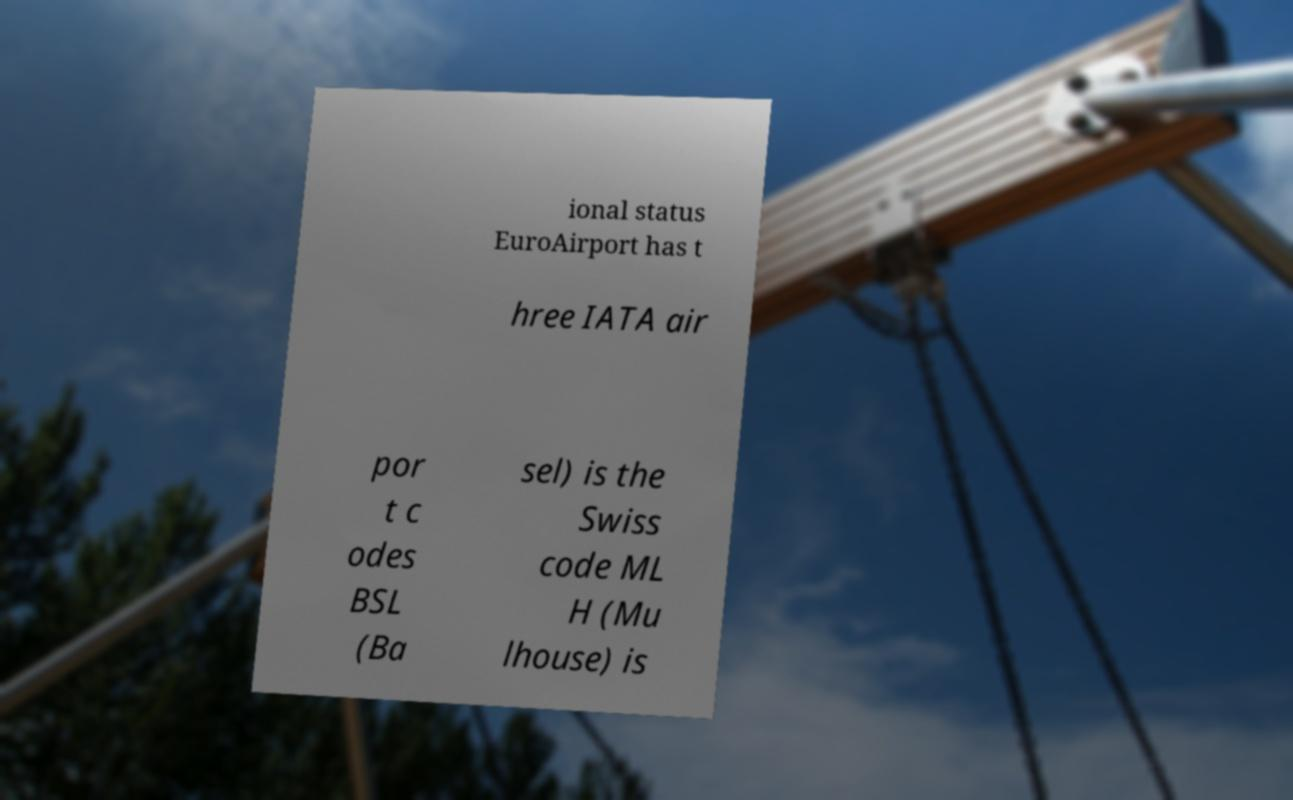Can you accurately transcribe the text from the provided image for me? ional status EuroAirport has t hree IATA air por t c odes BSL (Ba sel) is the Swiss code ML H (Mu lhouse) is 